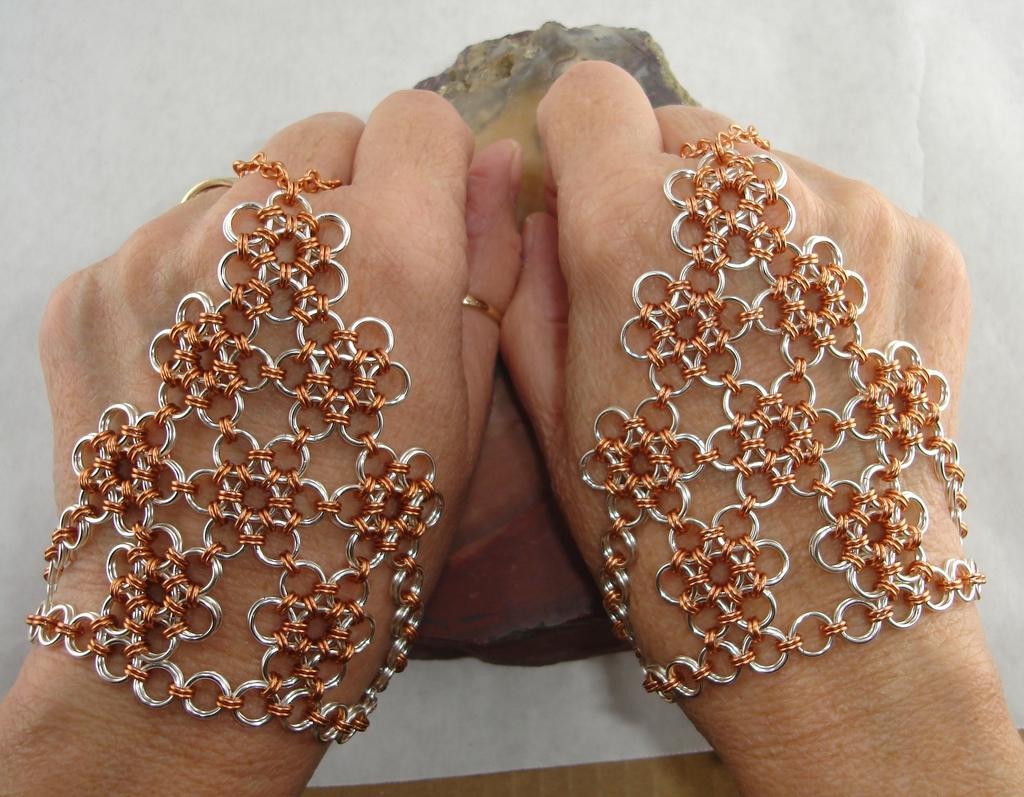Could you give a brief overview of what you see in this image? In this image I can see hand of a person and I can also see ring gloves on these hands. 